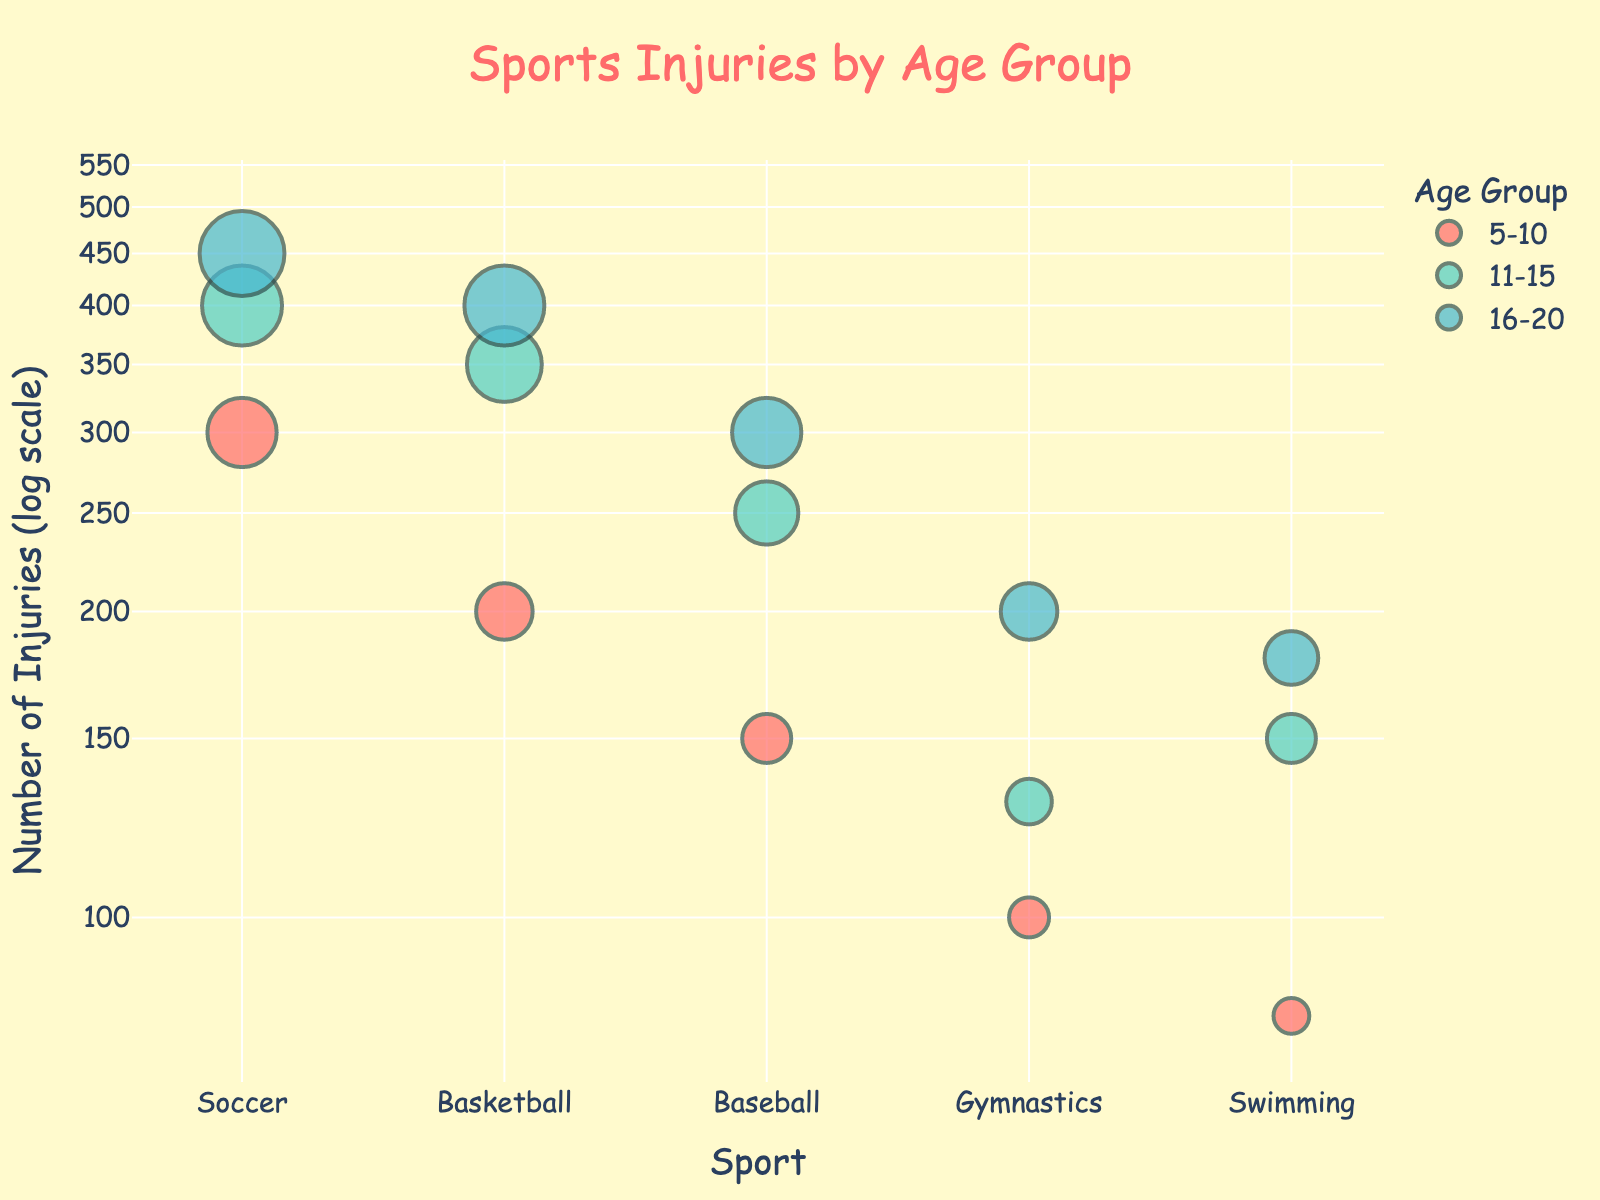what is the title of the plot? The title of the plot is displayed at the top center of the figure in a larger font size and colored text
Answer: Sports Injuries by Age Group Which age group has the highest number of injuries in Soccer? Look at the Soccer data points and compare the size of the circles corresponding to different age groups. The largest circle represents the age group with the highest number of injuries
Answer: 16-20 How many sports are included in the plot? Count the unique data points along the x-axis, each labeled with a different sport
Answer: 5 What is the difference in the number of Gymnastics injuries between the 5-10 and 16-20 age groups? Find the data points for Gymnastics in the 5-10 and 16-20 age groups, and subtract the value for the 5-10 age group from the value for the 16-20 age group (200 - 100)
Answer: 100 Which sport shows an increase in the number of injuries across all age groups? Look for sports where the size of the circles progressively increases from 5-10 to 11-15 to 16-20 age groups
Answer: Soccer Which age group reports the lowest number of injuries in Swimming? Examine the relationship between size of circles and age groups for Swimming and identify the smallest circle
Answer: 5-10 Which sport has more injuries in the 11-15 age group: Basketball or Swimming? Compare the sizes of the circles representing Basketball and Swimming within the 11-15 age group, the larger circle determines the sport with more injuries
Answer: Basketball What is the total number of injuries reported in Baseball for all age groups? Add the number of injuries reported for Baseball in each age group (150 + 250 + 300)
Answer: 700 What is the median number of injuries in the 11-15 age group? List all the numbers of injuries in the 11-15 age group, order them and find the middle value: 130, 150, 250, 350, 400
Answer: 250 Is the number of injuries for the 11-15 age group in Gymnastics greater than in Swimming? Compare the sizes of the circles for the 11-15 age group in Gymnastics and Swimming, Gymnastics has a slightly smaller sized circle
Answer: No 